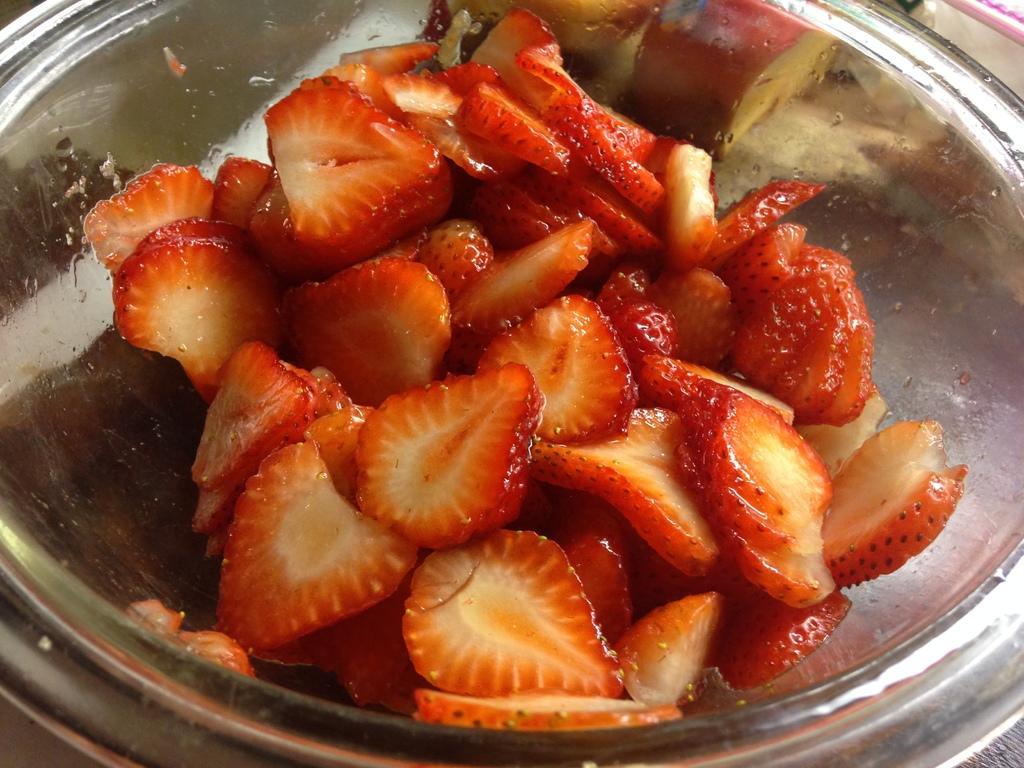Can you describe this image briefly? In this image I can see the food in the bowl and the food is in red and cream color. 